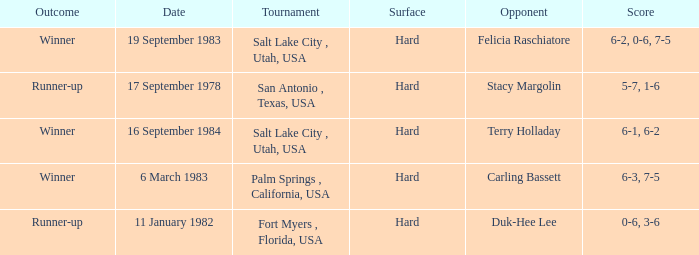What was the score of the match against duk-hee lee? 0-6, 3-6. 